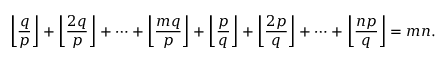Convert formula to latex. <formula><loc_0><loc_0><loc_500><loc_500>\left \lfloor { \frac { q } { p } } \right \rfloor + \left \lfloor { \frac { 2 q } { p } } \right \rfloor + \dots + \left \lfloor { \frac { m q } { p } } \right \rfloor + \left \lfloor { \frac { p } { q } } \right \rfloor + \left \lfloor { \frac { 2 p } { q } } \right \rfloor + \dots + \left \lfloor { \frac { n p } { q } } \right \rfloor = m n .</formula> 